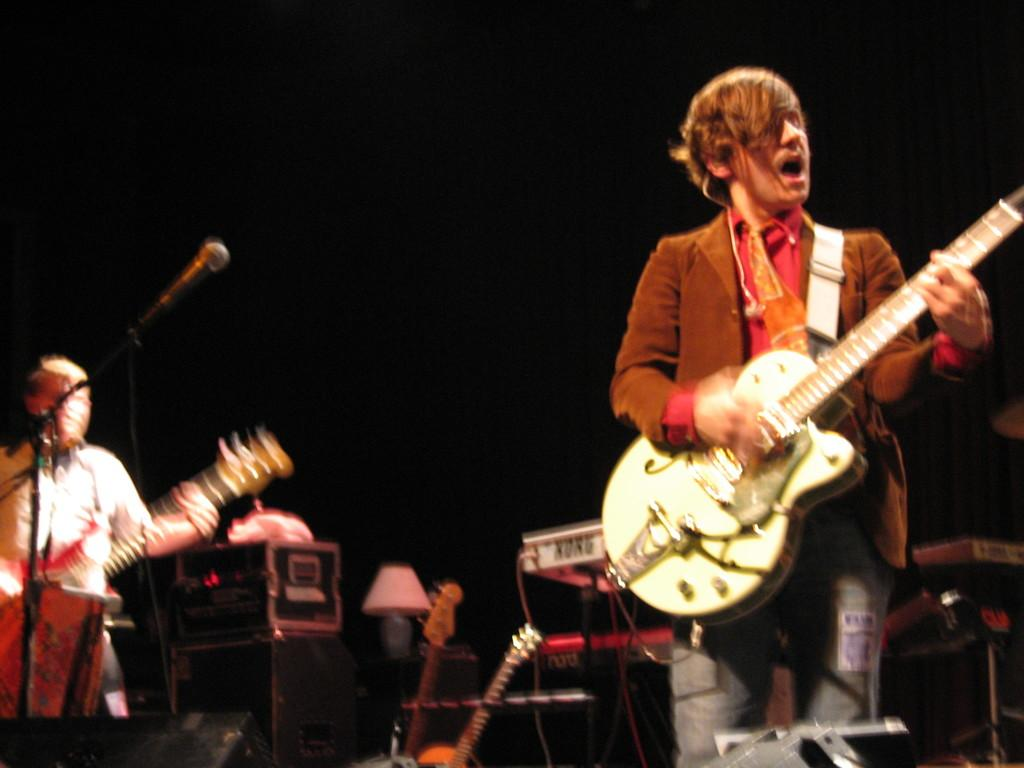What is the person in the image doing? The person in the image is playing a guitar. Are there any other musical instruments visible in the image? Yes, there are guitars, a piano, and a microphone visible in the background. Can you describe the background of the image? The background includes a lamp, guitars, a piano, and a microphone. Are there any other people in the image? Yes, there is another person playing a guitar in the background. Can you tell me where the library is located in the image? There is no library present in the image. Is there a bat flying around in the image? There is no bat visible in the image. 